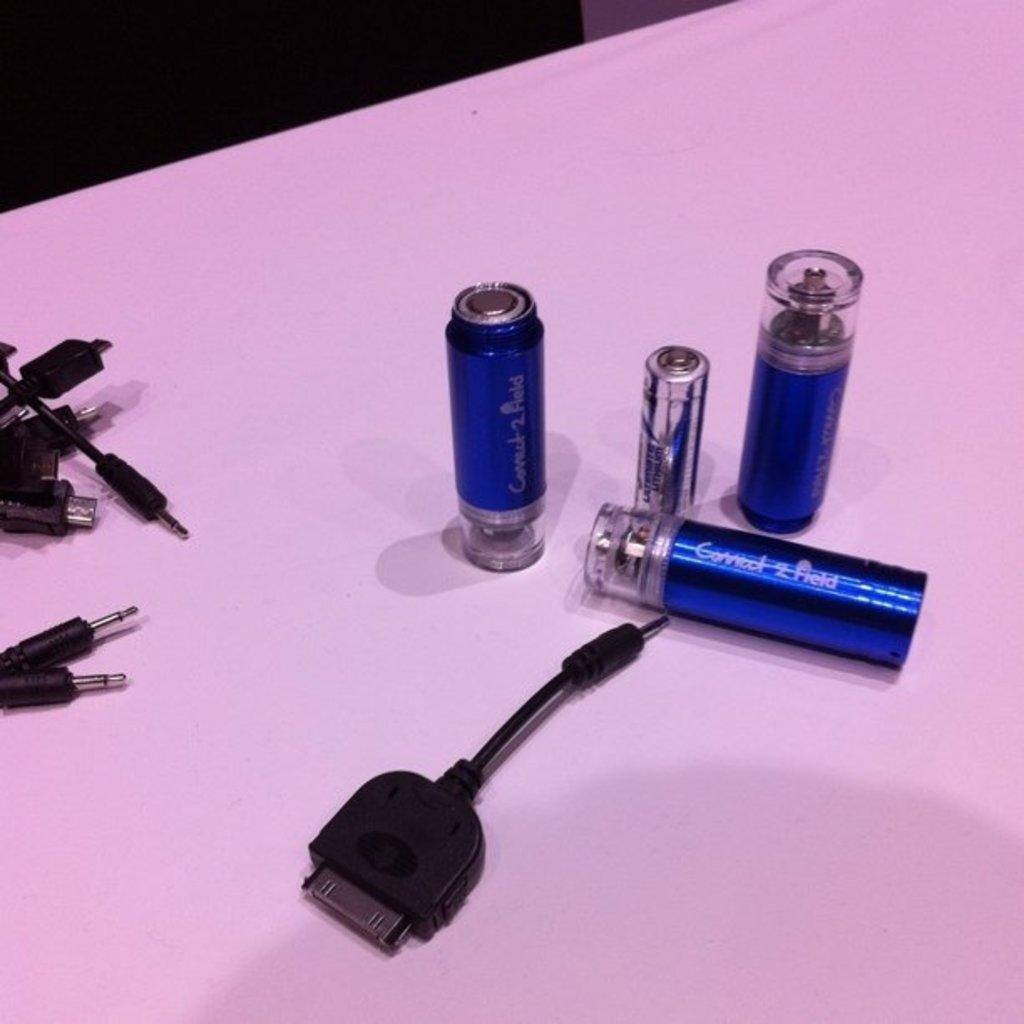<image>
Offer a succinct explanation of the picture presented. Some small, blue devices have Connect 2 Field printed on them. 